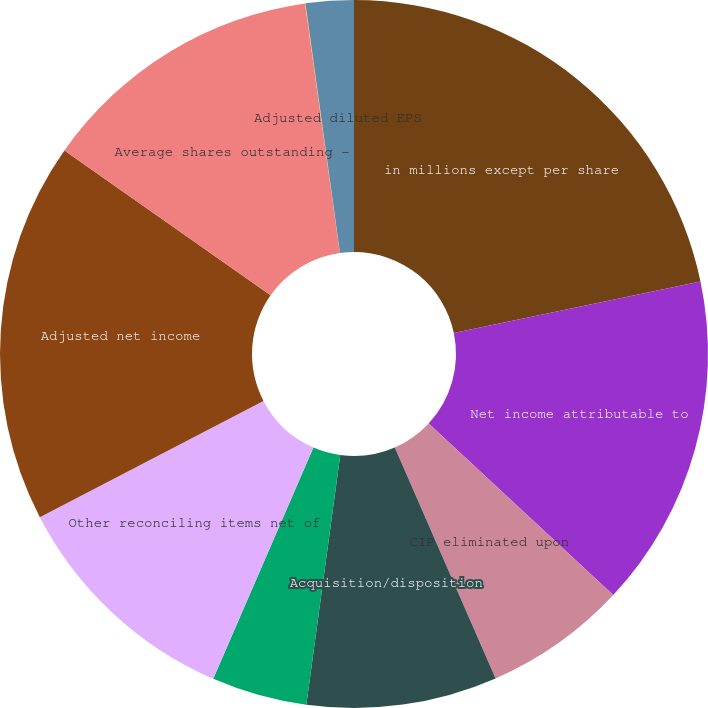Convert chart. <chart><loc_0><loc_0><loc_500><loc_500><pie_chart><fcel>in millions except per share<fcel>Net income attributable to<fcel>CIP eliminated upon<fcel>Acquisition/disposition<fcel>Deferred compensation plan<fcel>Other reconciling items net of<fcel>Adjusted net income<fcel>Average shares outstanding -<fcel>Diluted EPS<fcel>Adjusted diluted EPS<nl><fcel>21.72%<fcel>15.21%<fcel>6.53%<fcel>8.7%<fcel>4.36%<fcel>10.87%<fcel>17.38%<fcel>13.04%<fcel>0.02%<fcel>2.19%<nl></chart> 